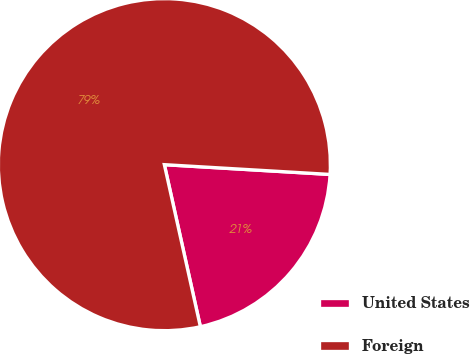Convert chart. <chart><loc_0><loc_0><loc_500><loc_500><pie_chart><fcel>United States<fcel>Foreign<nl><fcel>20.58%<fcel>79.42%<nl></chart> 